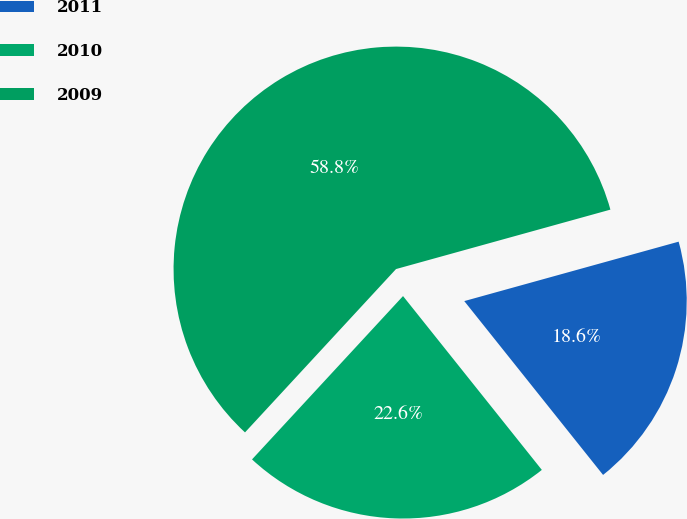Convert chart. <chart><loc_0><loc_0><loc_500><loc_500><pie_chart><fcel>2011<fcel>2010<fcel>2009<nl><fcel>18.58%<fcel>22.6%<fcel>58.82%<nl></chart> 